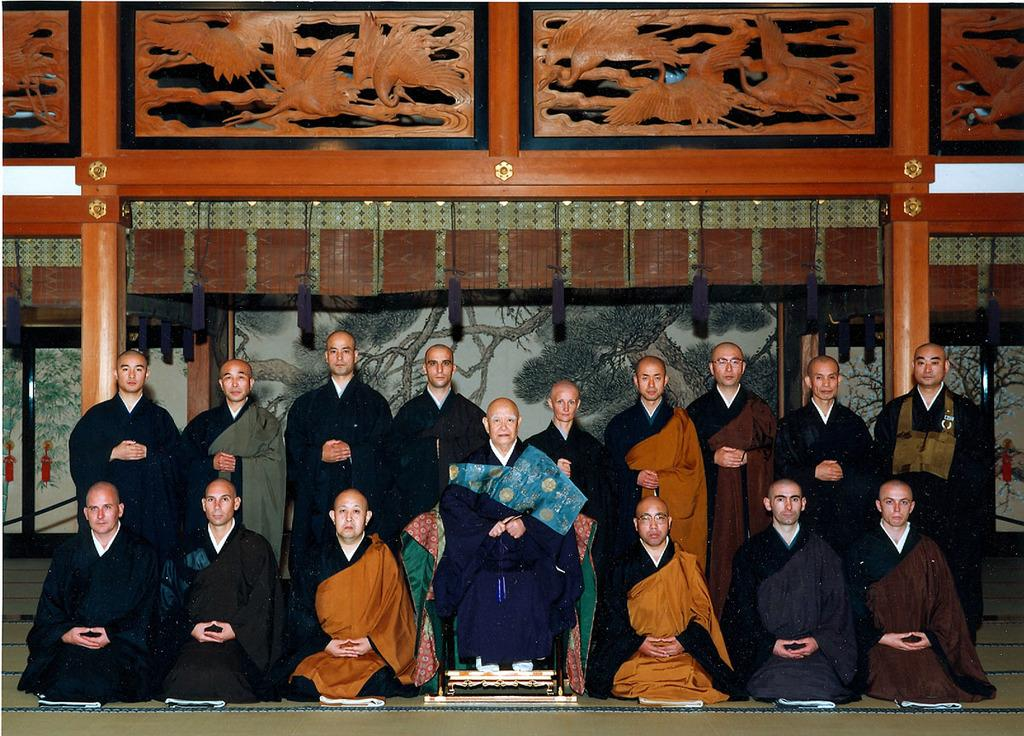How many people are in the image? There are people in the image, but the exact number is not specified. What is the position of one of the people in the image? One person is sitting on a chair in the image. What can be seen in the background of the image? There is a wall in the background of the image. What is on the wall in the image? There is a painting on the wall in the image. What type of decorative elements are present in the image? There are wooden carved designs in the image. What type of grain is being harvested by the people in the image? There is no indication of any grain or harvesting activity in the image. 